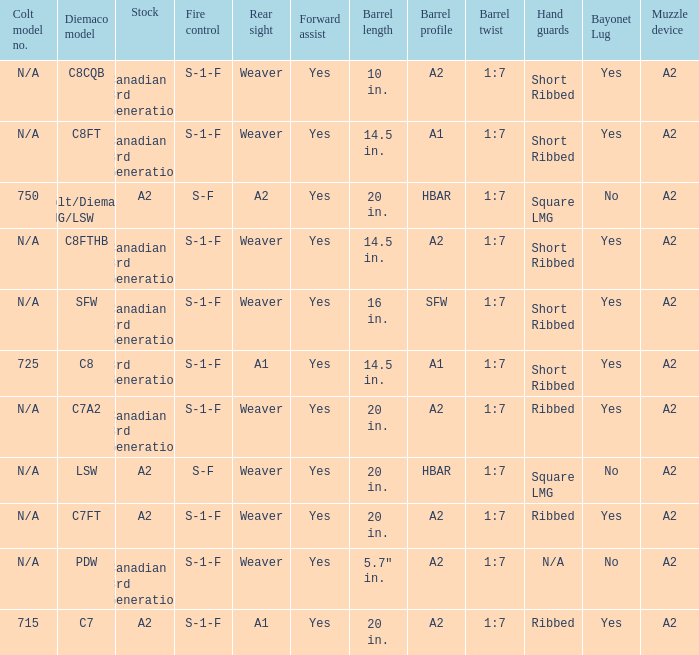Which Barrel twist has a Stock of canadian 3rd generation and a Hand guards of short ribbed? 1:7, 1:7, 1:7, 1:7. 